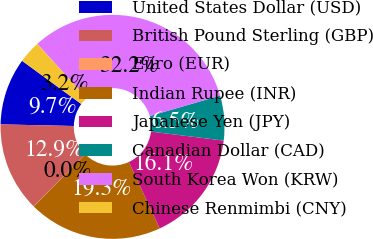Convert chart. <chart><loc_0><loc_0><loc_500><loc_500><pie_chart><fcel>United States Dollar (USD)<fcel>British Pound Sterling (GBP)<fcel>Euro (EUR)<fcel>Indian Rupee (INR)<fcel>Japanese Yen (JPY)<fcel>Canadian Dollar (CAD)<fcel>South Korea Won (KRW)<fcel>Chinese Renmimbi (CNY)<nl><fcel>9.68%<fcel>12.9%<fcel>0.03%<fcel>19.34%<fcel>16.12%<fcel>6.46%<fcel>32.22%<fcel>3.24%<nl></chart> 